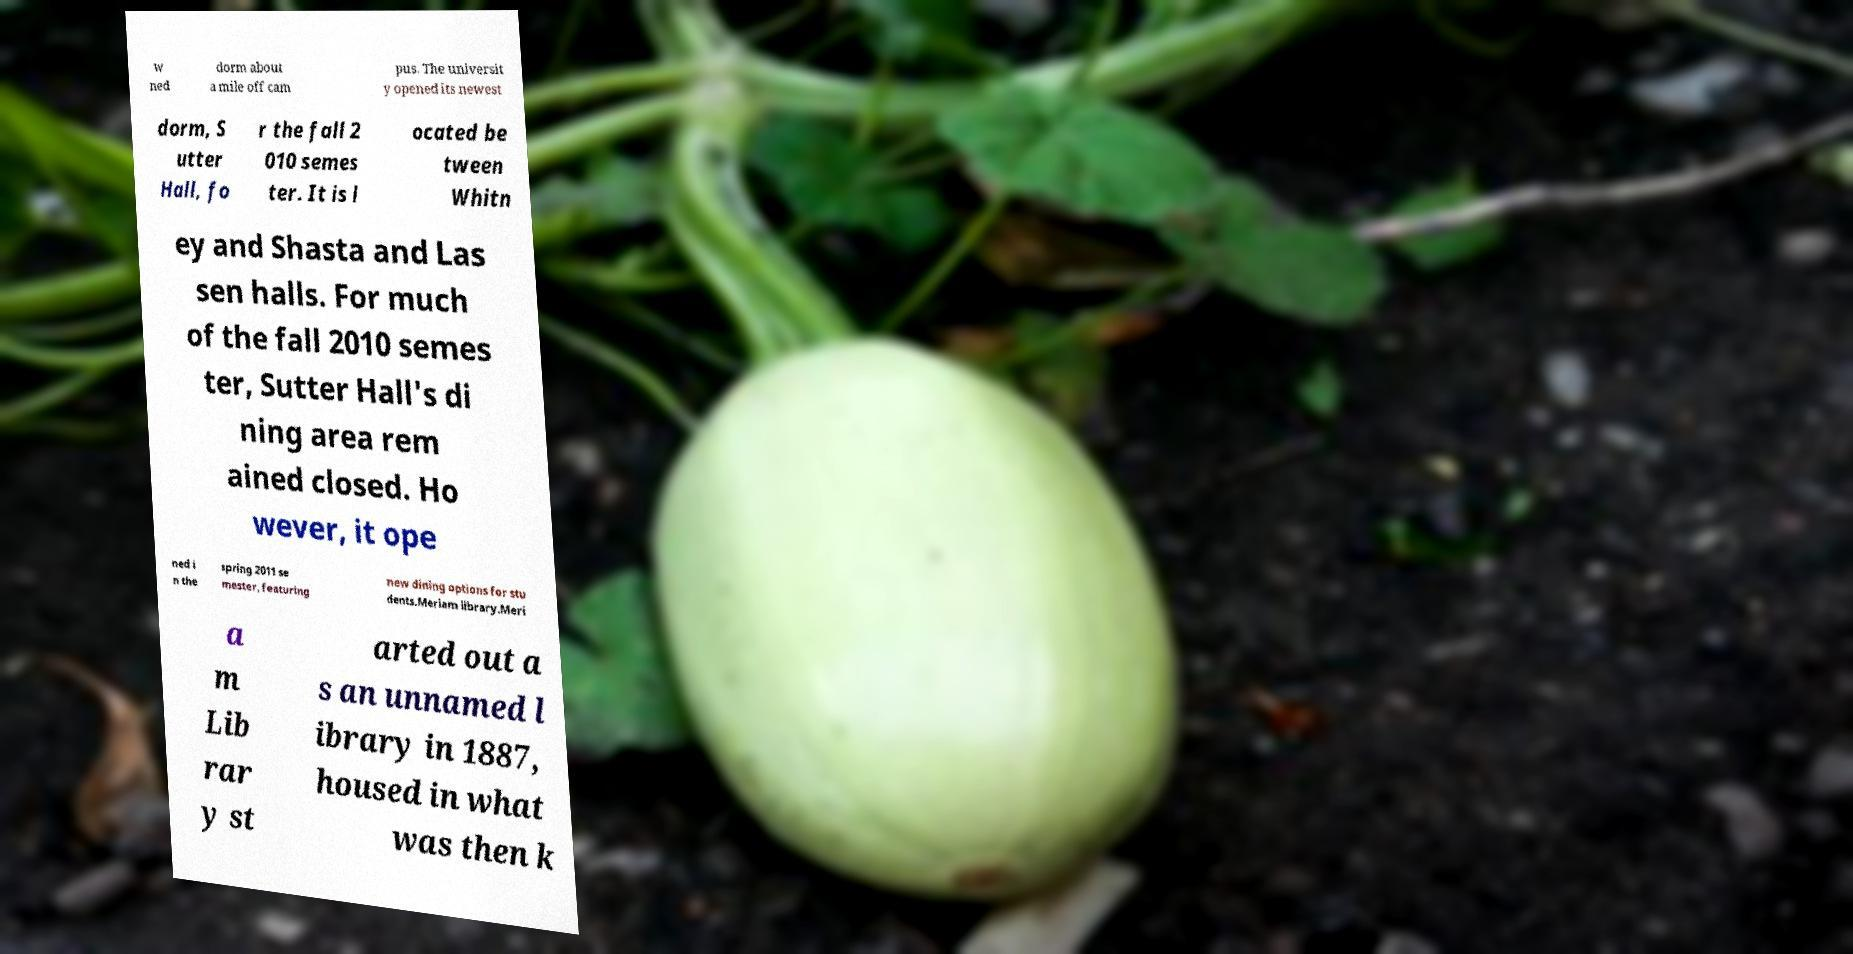Can you read and provide the text displayed in the image?This photo seems to have some interesting text. Can you extract and type it out for me? w ned dorm about a mile off cam pus. The universit y opened its newest dorm, S utter Hall, fo r the fall 2 010 semes ter. It is l ocated be tween Whitn ey and Shasta and Las sen halls. For much of the fall 2010 semes ter, Sutter Hall's di ning area rem ained closed. Ho wever, it ope ned i n the spring 2011 se mester, featuring new dining options for stu dents.Meriam library.Meri a m Lib rar y st arted out a s an unnamed l ibrary in 1887, housed in what was then k 